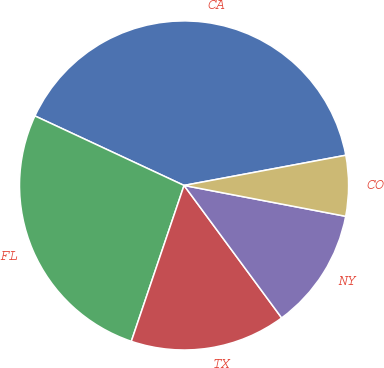Convert chart. <chart><loc_0><loc_0><loc_500><loc_500><pie_chart><fcel>CA<fcel>FL<fcel>TX<fcel>NY<fcel>CO<nl><fcel>40.12%<fcel>26.75%<fcel>15.3%<fcel>11.89%<fcel>5.94%<nl></chart> 